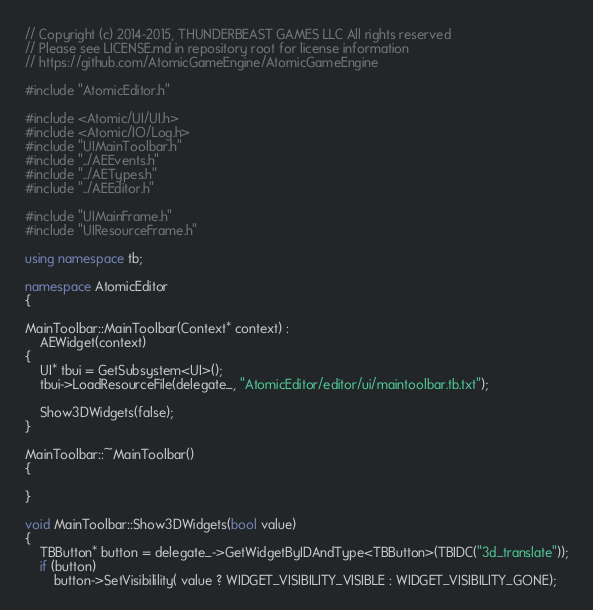Convert code to text. <code><loc_0><loc_0><loc_500><loc_500><_C++_>// Copyright (c) 2014-2015, THUNDERBEAST GAMES LLC All rights reserved
// Please see LICENSE.md in repository root for license information
// https://github.com/AtomicGameEngine/AtomicGameEngine

#include "AtomicEditor.h"

#include <Atomic/UI/UI.h>
#include <Atomic/IO/Log.h>
#include "UIMainToolbar.h"
#include "../AEEvents.h"
#include "../AETypes.h"
#include "../AEEditor.h"

#include "UIMainFrame.h"
#include "UIResourceFrame.h"

using namespace tb;

namespace AtomicEditor
{

MainToolbar::MainToolbar(Context* context) :
    AEWidget(context)
{
    UI* tbui = GetSubsystem<UI>();
    tbui->LoadResourceFile(delegate_, "AtomicEditor/editor/ui/maintoolbar.tb.txt");

    Show3DWidgets(false);
}

MainToolbar::~MainToolbar()
{

}

void MainToolbar::Show3DWidgets(bool value)
{
    TBButton* button = delegate_->GetWidgetByIDAndType<TBButton>(TBIDC("3d_translate"));
    if (button)
        button->SetVisibilility( value ? WIDGET_VISIBILITY_VISIBLE : WIDGET_VISIBILITY_GONE);
</code> 